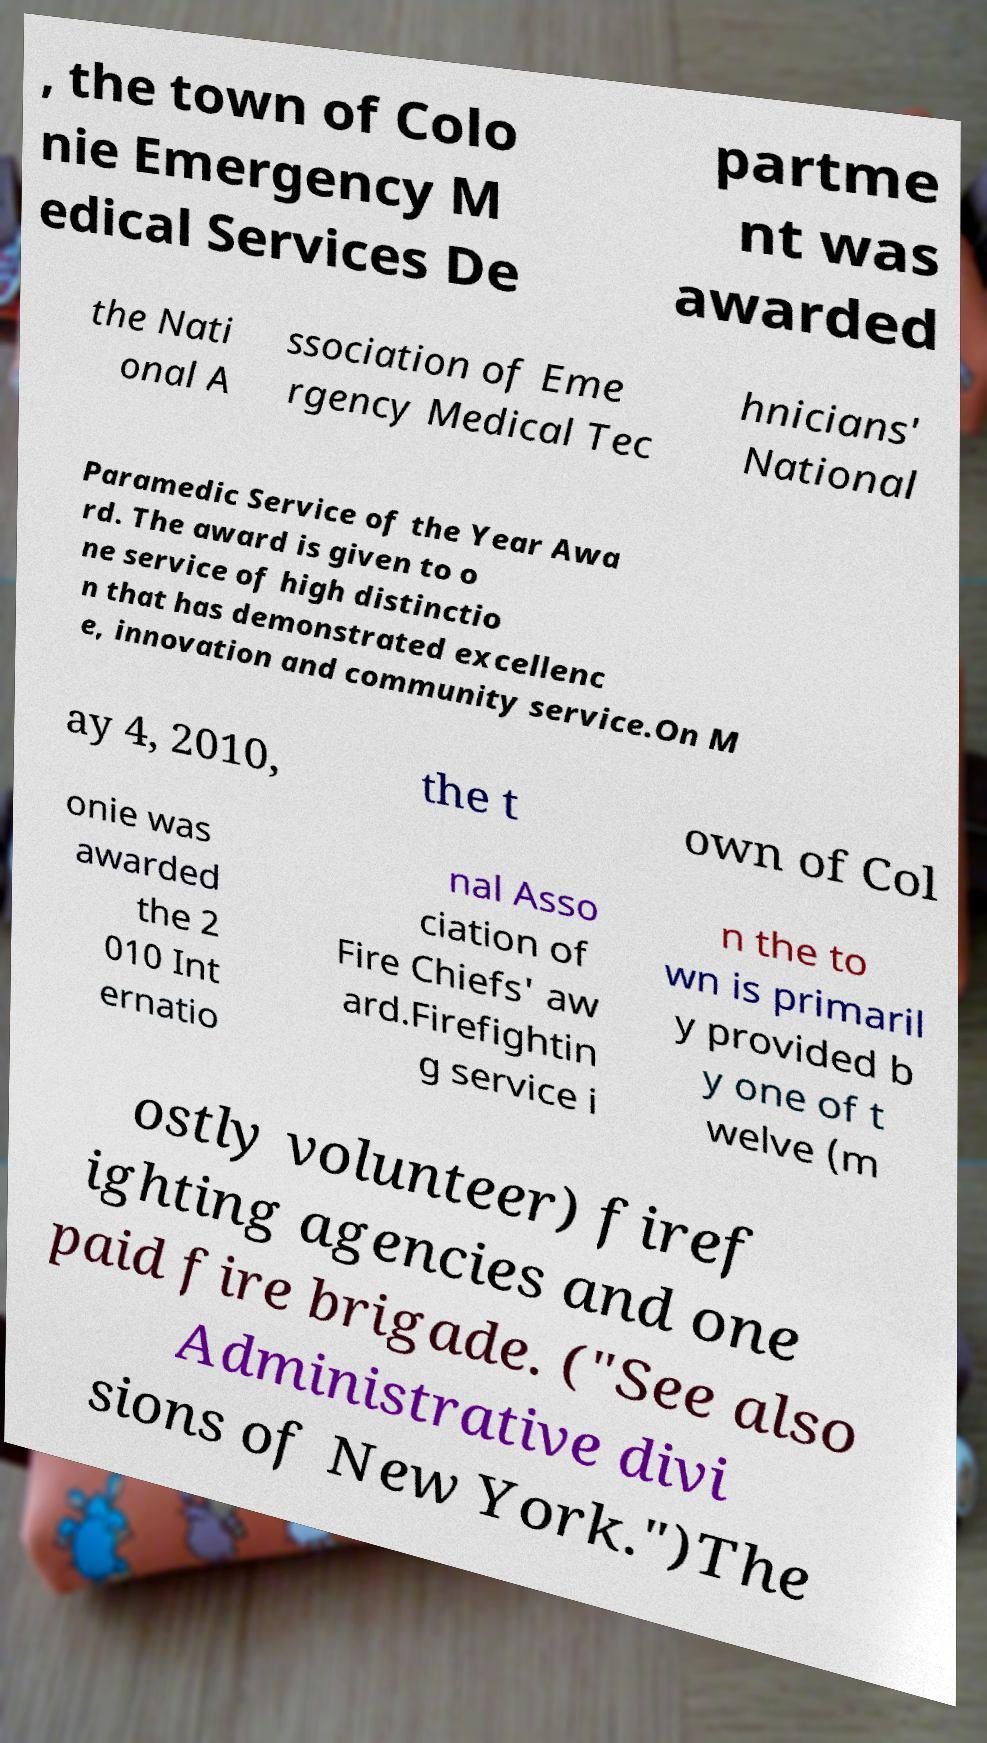I need the written content from this picture converted into text. Can you do that? , the town of Colo nie Emergency M edical Services De partme nt was awarded the Nati onal A ssociation of Eme rgency Medical Tec hnicians' National Paramedic Service of the Year Awa rd. The award is given to o ne service of high distinctio n that has demonstrated excellenc e, innovation and community service.On M ay 4, 2010, the t own of Col onie was awarded the 2 010 Int ernatio nal Asso ciation of Fire Chiefs' aw ard.Firefightin g service i n the to wn is primaril y provided b y one of t welve (m ostly volunteer) firef ighting agencies and one paid fire brigade. ("See also Administrative divi sions of New York.")The 